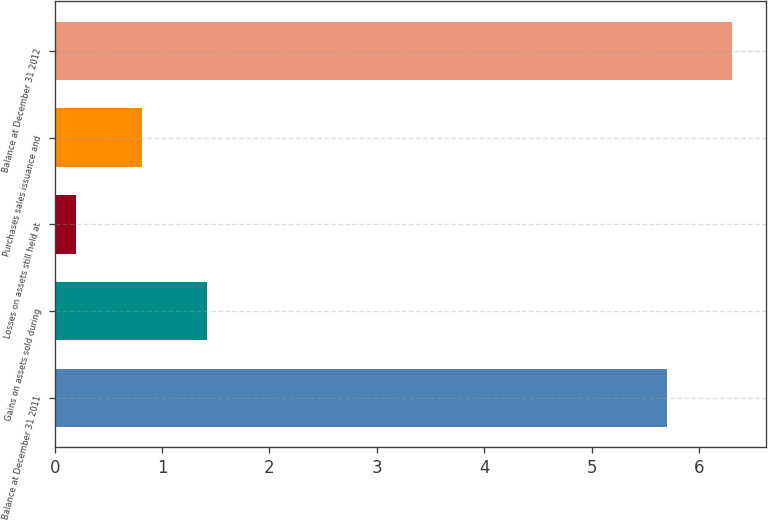<chart> <loc_0><loc_0><loc_500><loc_500><bar_chart><fcel>Balance at December 31 2011<fcel>Gains on assets sold during<fcel>Losses on assets still held at<fcel>Purchases sales issuance and<fcel>Balance at December 31 2012<nl><fcel>5.7<fcel>1.42<fcel>0.2<fcel>0.81<fcel>6.31<nl></chart> 